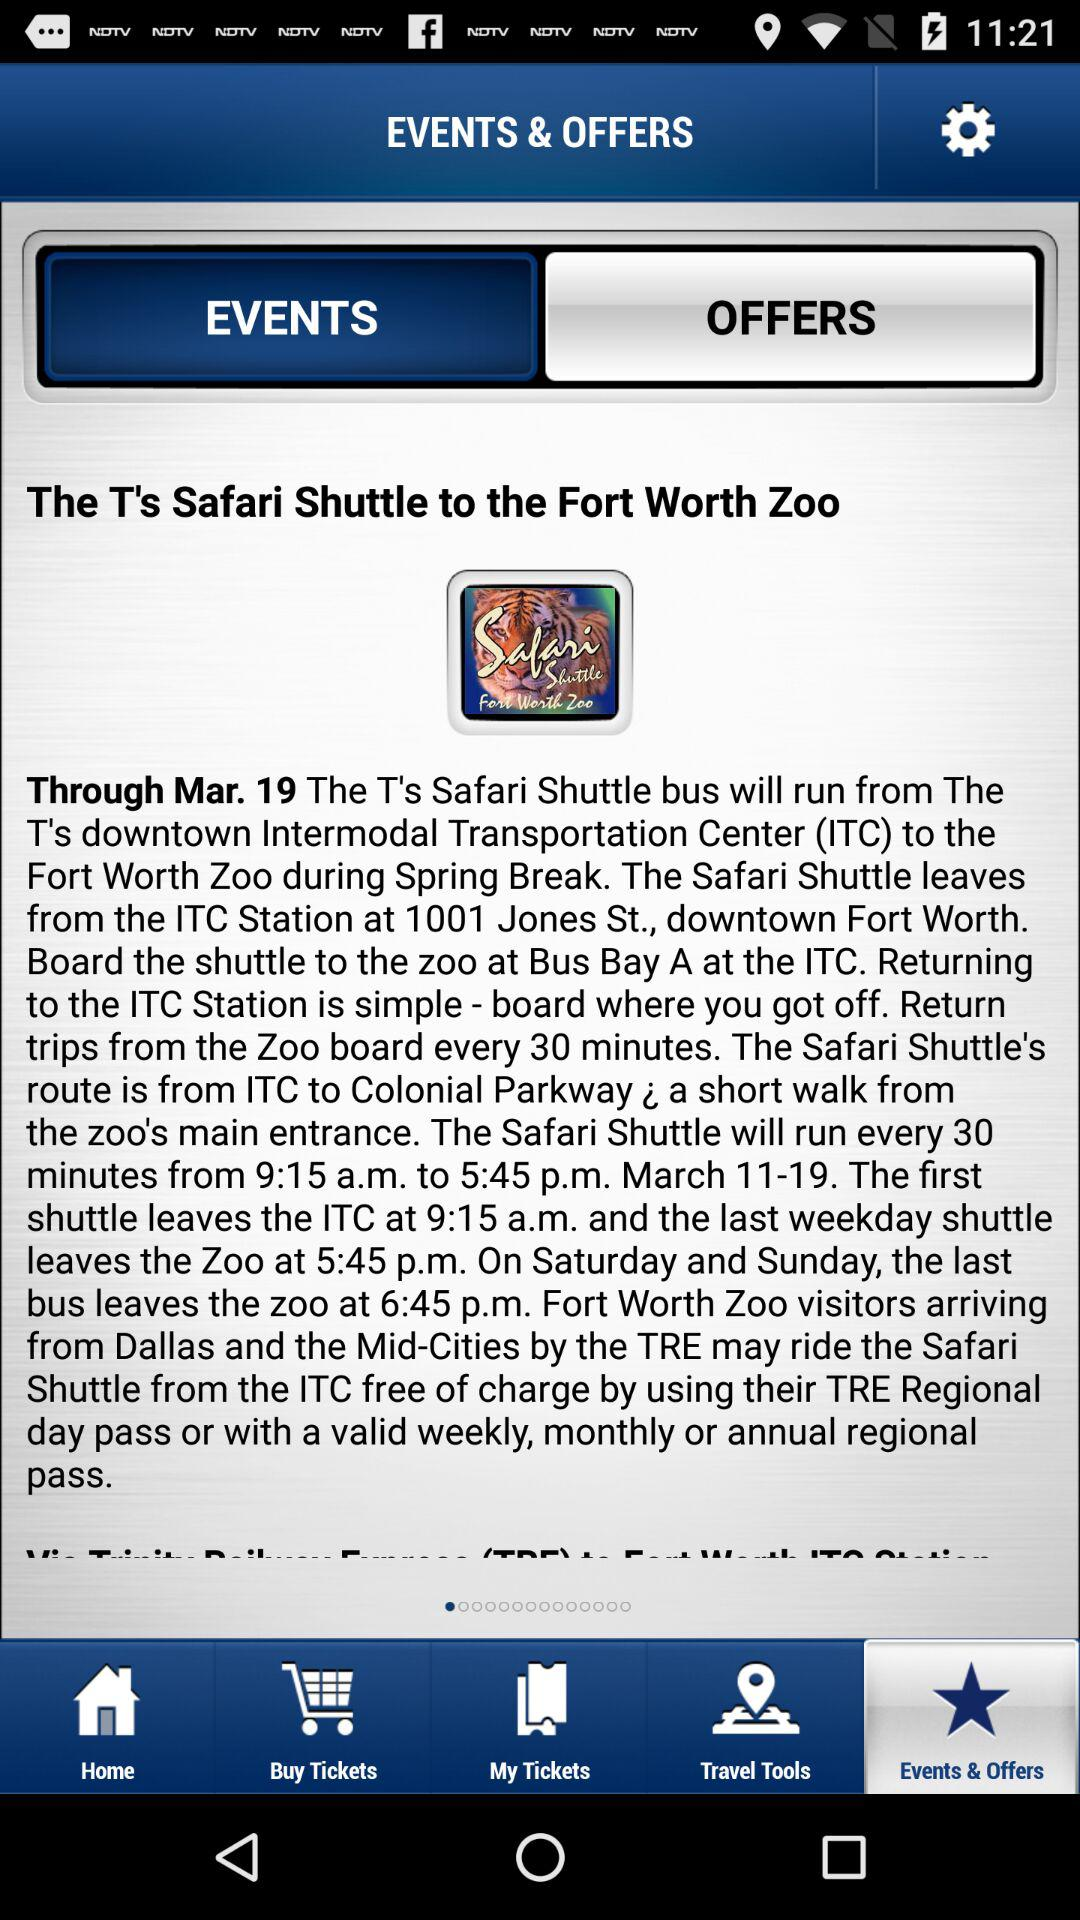Which option has been selected? The options that have been selected are "EVENTS" and "Events & Offers". 